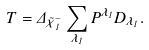Convert formula to latex. <formula><loc_0><loc_0><loc_500><loc_500>T = \Delta _ { \tilde { \chi } ^ { - } _ { 1 } } \sum _ { \lambda _ { 1 } } P ^ { \lambda _ { 1 } } D _ { \lambda _ { 1 } } .</formula> 